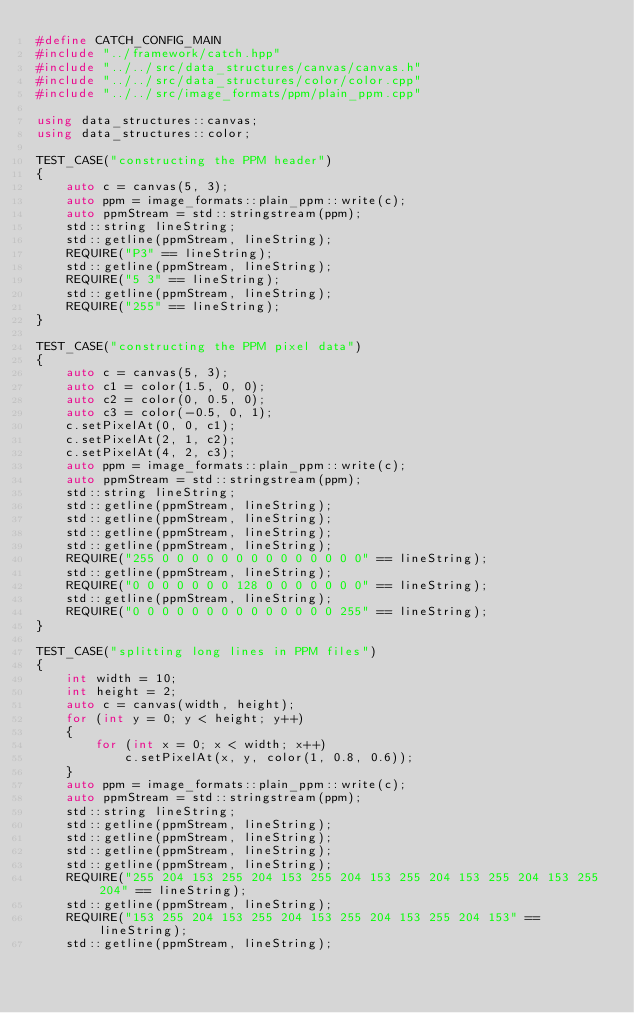<code> <loc_0><loc_0><loc_500><loc_500><_C++_>#define CATCH_CONFIG_MAIN
#include "../framework/catch.hpp"
#include "../../src/data_structures/canvas/canvas.h"
#include "../../src/data_structures/color/color.cpp"
#include "../../src/image_formats/ppm/plain_ppm.cpp"

using data_structures::canvas;
using data_structures::color;

TEST_CASE("constructing the PPM header")
{
	auto c = canvas(5, 3);
	auto ppm = image_formats::plain_ppm::write(c);
	auto ppmStream = std::stringstream(ppm);
	std::string lineString;
	std::getline(ppmStream, lineString);
	REQUIRE("P3" == lineString);
	std::getline(ppmStream, lineString);
	REQUIRE("5 3" == lineString);
	std::getline(ppmStream, lineString);
	REQUIRE("255" == lineString);
}

TEST_CASE("constructing the PPM pixel data")
{
	auto c = canvas(5, 3);
	auto c1 = color(1.5, 0, 0);
	auto c2 = color(0, 0.5, 0);
	auto c3 = color(-0.5, 0, 1);
	c.setPixelAt(0, 0, c1);
	c.setPixelAt(2, 1, c2);
	c.setPixelAt(4, 2, c3);
	auto ppm = image_formats::plain_ppm::write(c);
	auto ppmStream = std::stringstream(ppm);
	std::string lineString;
	std::getline(ppmStream, lineString);
	std::getline(ppmStream, lineString);
	std::getline(ppmStream, lineString);
	std::getline(ppmStream, lineString);
	REQUIRE("255 0 0 0 0 0 0 0 0 0 0 0 0 0 0" == lineString);
	std::getline(ppmStream, lineString);
	REQUIRE("0 0 0 0 0 0 0 128 0 0 0 0 0 0 0" == lineString);
	std::getline(ppmStream, lineString);
	REQUIRE("0 0 0 0 0 0 0 0 0 0 0 0 0 0 255" == lineString);
}

TEST_CASE("splitting long lines in PPM files")
{
	int width = 10;
	int height = 2;
	auto c = canvas(width, height);
	for (int y = 0; y < height; y++)
	{
		for (int x = 0; x < width; x++)
			c.setPixelAt(x, y, color(1, 0.8, 0.6));
	}
	auto ppm = image_formats::plain_ppm::write(c);
	auto ppmStream = std::stringstream(ppm);
	std::string lineString;
	std::getline(ppmStream, lineString);
	std::getline(ppmStream, lineString);
	std::getline(ppmStream, lineString);
	std::getline(ppmStream, lineString);
	REQUIRE("255 204 153 255 204 153 255 204 153 255 204 153 255 204 153 255 204" == lineString);
	std::getline(ppmStream, lineString);
	REQUIRE("153 255 204 153 255 204 153 255 204 153 255 204 153" == lineString);
	std::getline(ppmStream, lineString);</code> 